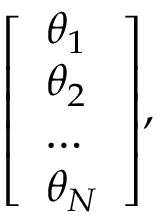<formula> <loc_0><loc_0><loc_500><loc_500>{ \left [ \begin{array} { l } { \theta _ { 1 } } \\ { \theta _ { 2 } } \\ { \dots } \\ { \theta _ { N } } \end{array} \right ] } ,</formula> 